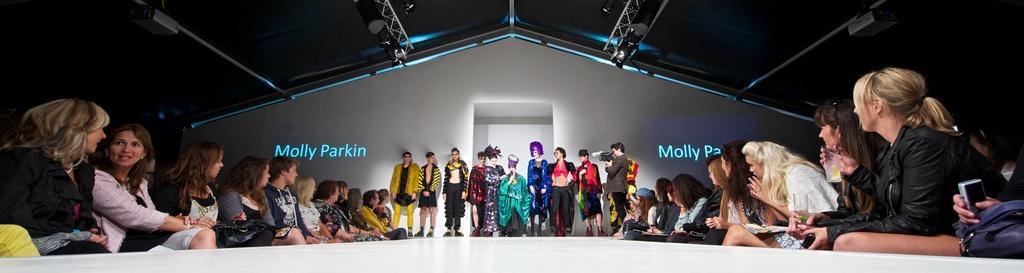Can you describe this image briefly? There are some persons on the left and on the right side of the image. There is a ramp at the bottom of the image. There are some persons standing and wearing clothes in the middle of the image. 